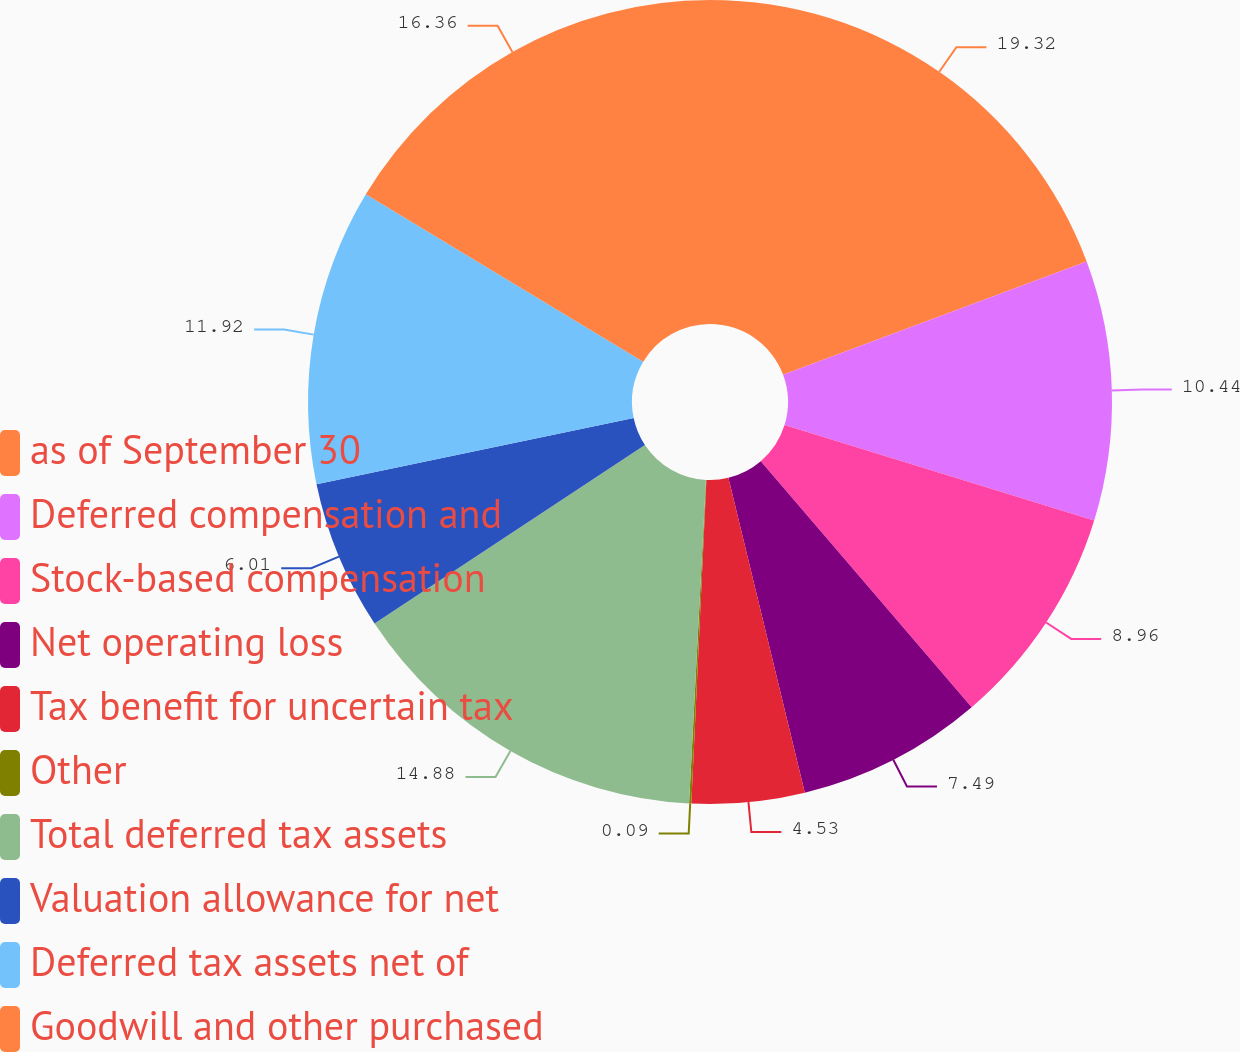Convert chart to OTSL. <chart><loc_0><loc_0><loc_500><loc_500><pie_chart><fcel>as of September 30<fcel>Deferred compensation and<fcel>Stock-based compensation<fcel>Net operating loss<fcel>Tax benefit for uncertain tax<fcel>Other<fcel>Total deferred tax assets<fcel>Valuation allowance for net<fcel>Deferred tax assets net of<fcel>Goodwill and other purchased<nl><fcel>19.32%<fcel>10.44%<fcel>8.96%<fcel>7.49%<fcel>4.53%<fcel>0.09%<fcel>14.88%<fcel>6.01%<fcel>11.92%<fcel>16.36%<nl></chart> 